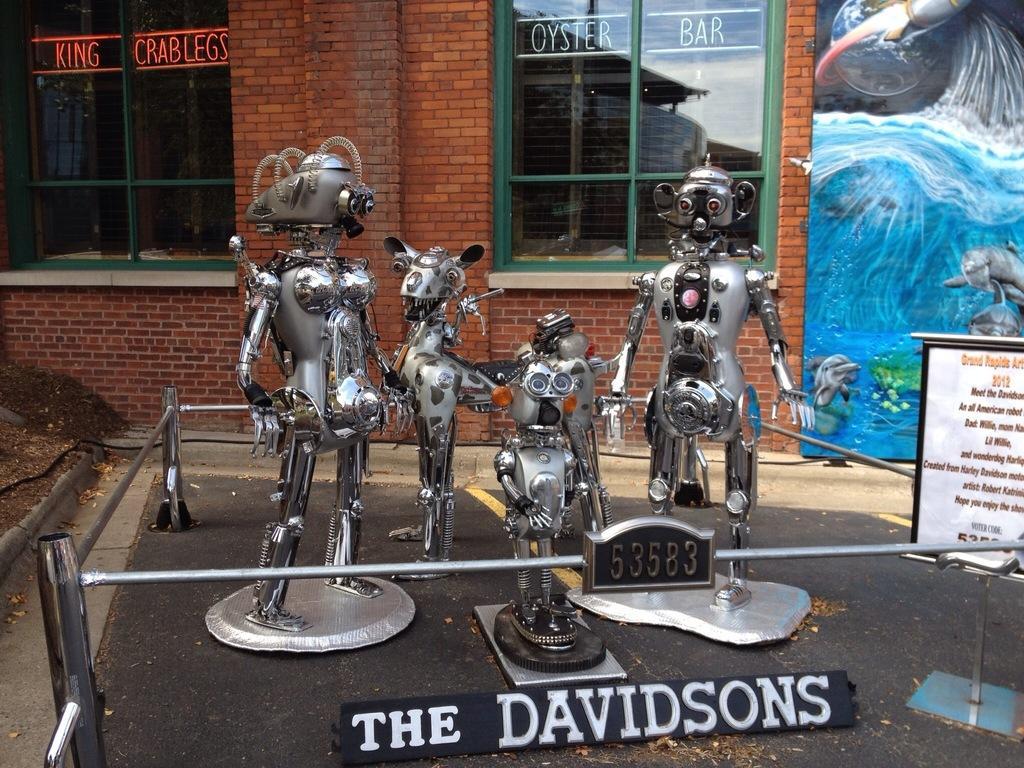Could you give a brief overview of what you see in this image? In this image, I can see the robots, iron rods and a name board on the road. On the right side of the image, I can see two boards. In the background, there is a wall with the glass windows. 